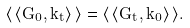<formula> <loc_0><loc_0><loc_500><loc_500>\langle \, \langle G _ { 0 } , k _ { t } \rangle \, \rangle = \langle \, \langle G _ { t } , k _ { 0 } \rangle \, \rangle .</formula> 